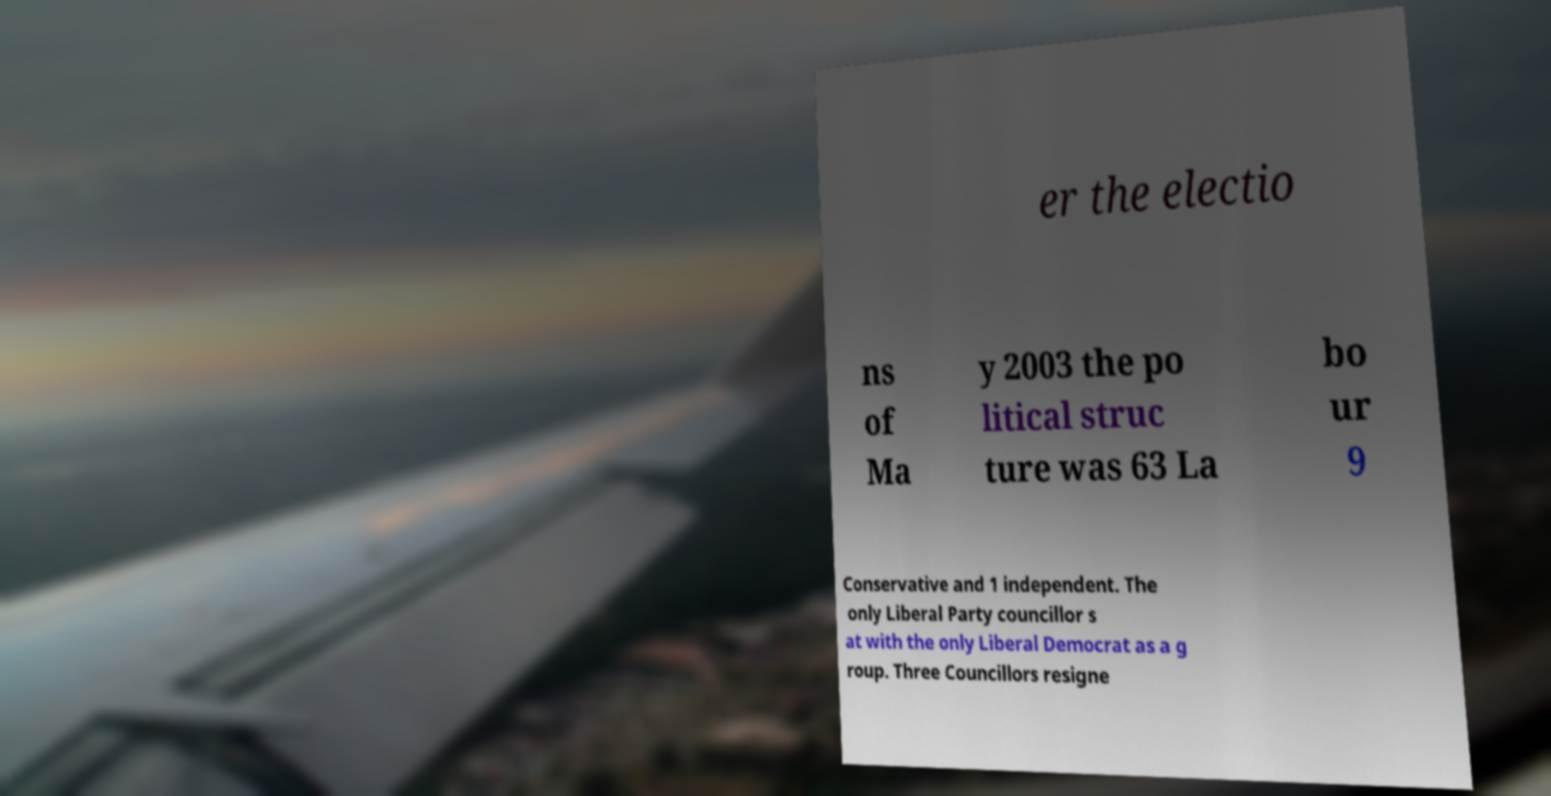Can you accurately transcribe the text from the provided image for me? er the electio ns of Ma y 2003 the po litical struc ture was 63 La bo ur 9 Conservative and 1 independent. The only Liberal Party councillor s at with the only Liberal Democrat as a g roup. Three Councillors resigne 